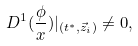<formula> <loc_0><loc_0><loc_500><loc_500>D ^ { 1 } ( \frac { \phi } { x } ) | _ { ( t ^ { * } , \vec { z } _ { i } ) } \neq 0 ,</formula> 